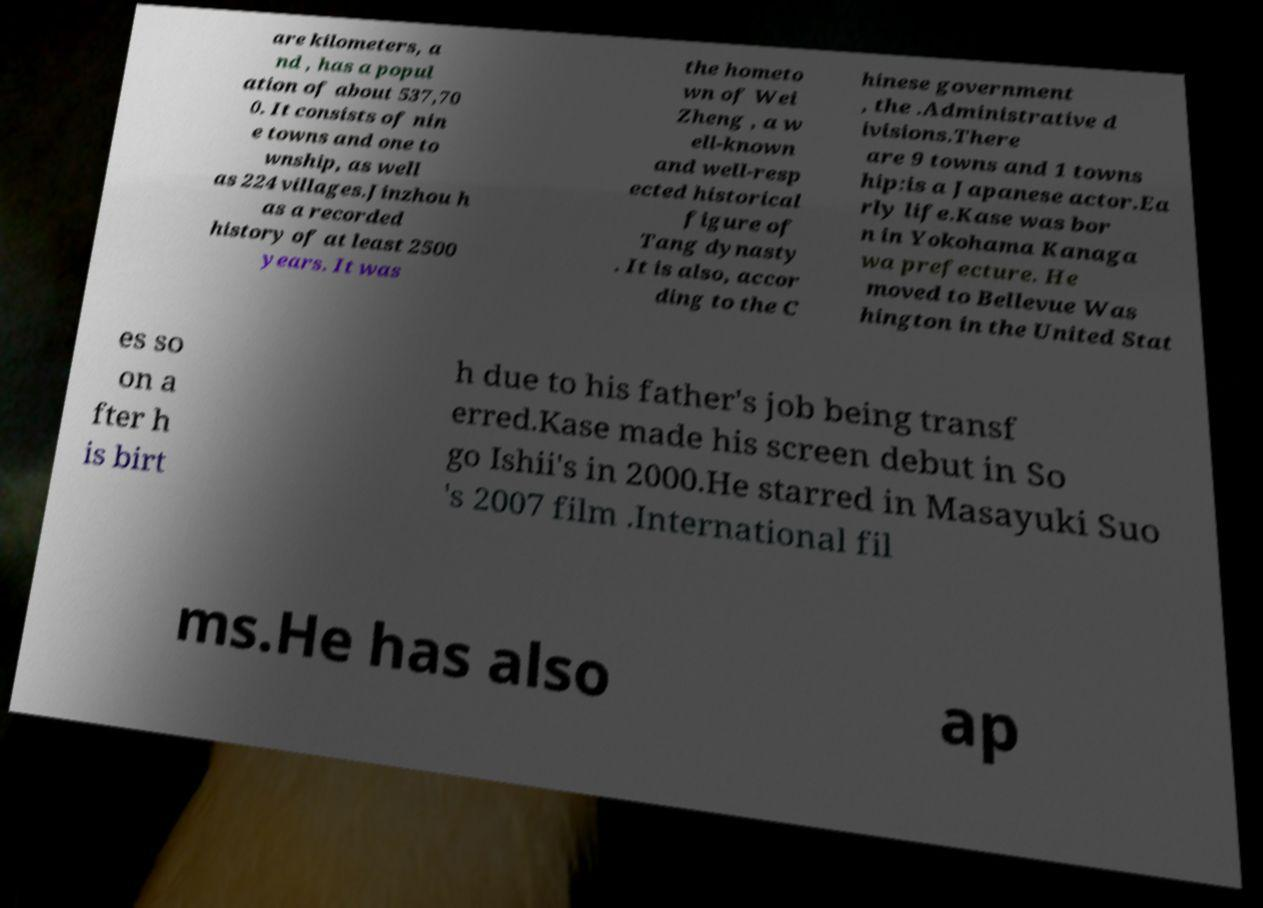What messages or text are displayed in this image? I need them in a readable, typed format. are kilometers, a nd , has a popul ation of about 537,70 0. It consists of nin e towns and one to wnship, as well as 224 villages.Jinzhou h as a recorded history of at least 2500 years. It was the hometo wn of Wei Zheng , a w ell-known and well-resp ected historical figure of Tang dynasty . It is also, accor ding to the C hinese government , the .Administrative d ivisions.There are 9 towns and 1 towns hip:is a Japanese actor.Ea rly life.Kase was bor n in Yokohama Kanaga wa prefecture. He moved to Bellevue Was hington in the United Stat es so on a fter h is birt h due to his father's job being transf erred.Kase made his screen debut in So go Ishii's in 2000.He starred in Masayuki Suo 's 2007 film .International fil ms.He has also ap 